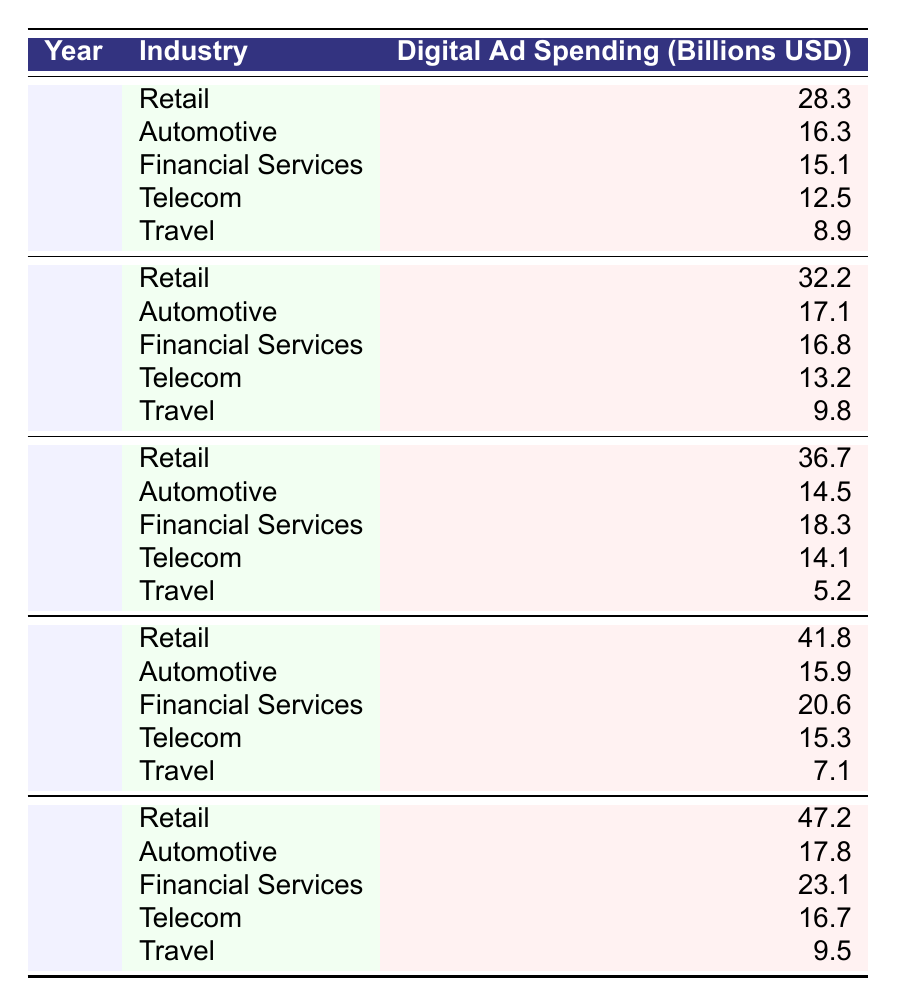What was the digital ad spending for the Automotive industry in 2019? In the table, I look for the row where the year is 2019 and the industry is Automotive. The value in that row is 17.1 billion USD.
Answer: 17.1 billion USD Which industry had the highest digital ad spending in 2022? I scan the 2022 rows and find that the Retail industry has the highest spending at 47.2 billion USD.
Answer: Retail What was the total digital ad spending for the Travel industry over the five years? I add the spending for Travel across all five years: 8.9 + 9.8 + 5.2 + 7.1 + 9.5 = 40.5 billion USD.
Answer: 40.5 billion USD Was the digital ad spending for Financial Services higher in 2020 or 2021? I compare the spending for Financial Services in both 2020 (18.3 billion USD) and 2021 (20.6 billion USD). Since 20.6 is greater than 18.3, 2021 had higher spending.
Answer: Yes, 2021 had higher spending What is the percentage increase in digital ad spending for Retail from 2018 to 2022? First, I find the spending for Retail in 2018 (28.3 billion USD) and in 2022 (47.2 billion USD). The increase is 47.2 - 28.3 = 18.9 billion USD. The percentage increase is (18.9 / 28.3) * 100 ≈ 66.8%.
Answer: Approximately 66.8% Which industry had the lowest digital ad spending in 2020? Looking at the 2020 row values, I find that the Travel industry had the lowest spending at 5.2 billion USD compared to the other industries.
Answer: Travel Calculate the average digital ad spending for the Automotive industry over the five years. I sum the values for Automotive: 16.3 + 17.1 + 14.5 + 15.9 + 17.8 = 81.6 billion USD. There are 5 data points, so the average is 81.6 / 5 = 16.32 billion USD.
Answer: 16.32 billion USD Did the digital ad spending for Telecom decline from 2019 to 2020? I check the Telecom spending for 2019 (13.2 billion USD) and for 2020 (14.1 billion USD). Since 14.1 is greater than 13.2, there was no decline.
Answer: No, it did not decline What is the combined digital ad spending for Financial Services in 2019 and 2020? I find the values for Financial Services: 2019 was 16.8 billion USD and 2020 was 18.3 billion USD. The combined sum is 16.8 + 18.3 = 35.1 billion USD.
Answer: 35.1 billion USD Which year's digital ad spending for Telecom was greater than 15 billion USD? I look through the Telecom values for each year and find that 2020 (14.1 billion USD) and 2018 (12.5 billion USD) were less than 15 billion USD. However, both 2021 and 2022 spending exceeded 15 billion.
Answer: 2021 and 2022 